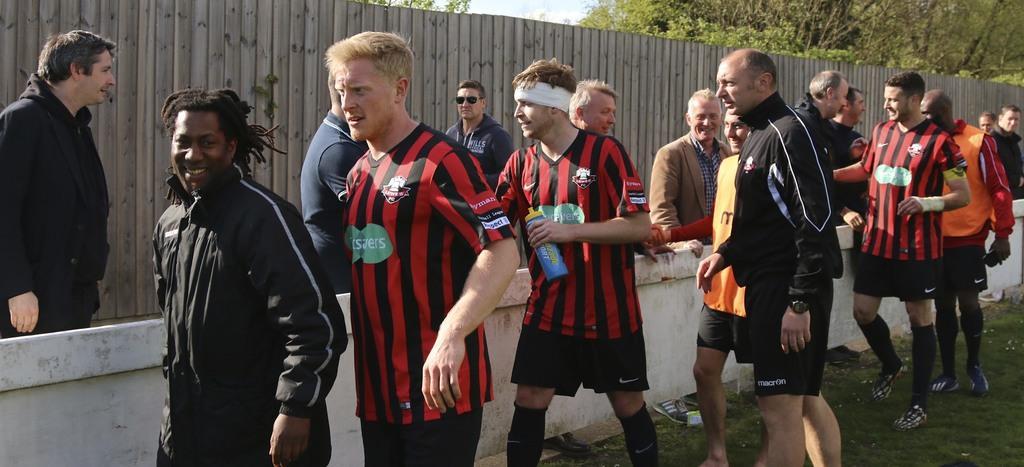Please provide a concise description of this image. In the image we can see there are many people standing, they are wearing clothes and shoes. This is a wrist watch, bottle, goggles, headband, grass, wooden fence, trees and a sky. 